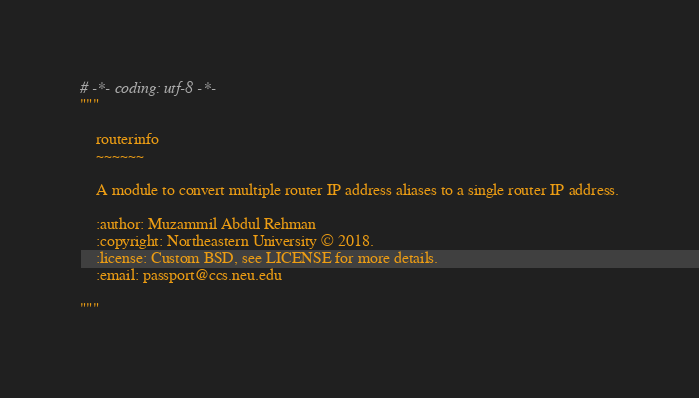Convert code to text. <code><loc_0><loc_0><loc_500><loc_500><_Python_># -*- coding: utf-8 -*-
"""

    routerinfo
    ~~~~~~

    A module to convert multiple router IP address aliases to a single router IP address.

    :author: Muzammil Abdul Rehman
    :copyright: Northeastern University © 2018.
    :license: Custom BSD, see LICENSE for more details.
    :email: passport@ccs.neu.edu

"""
</code> 